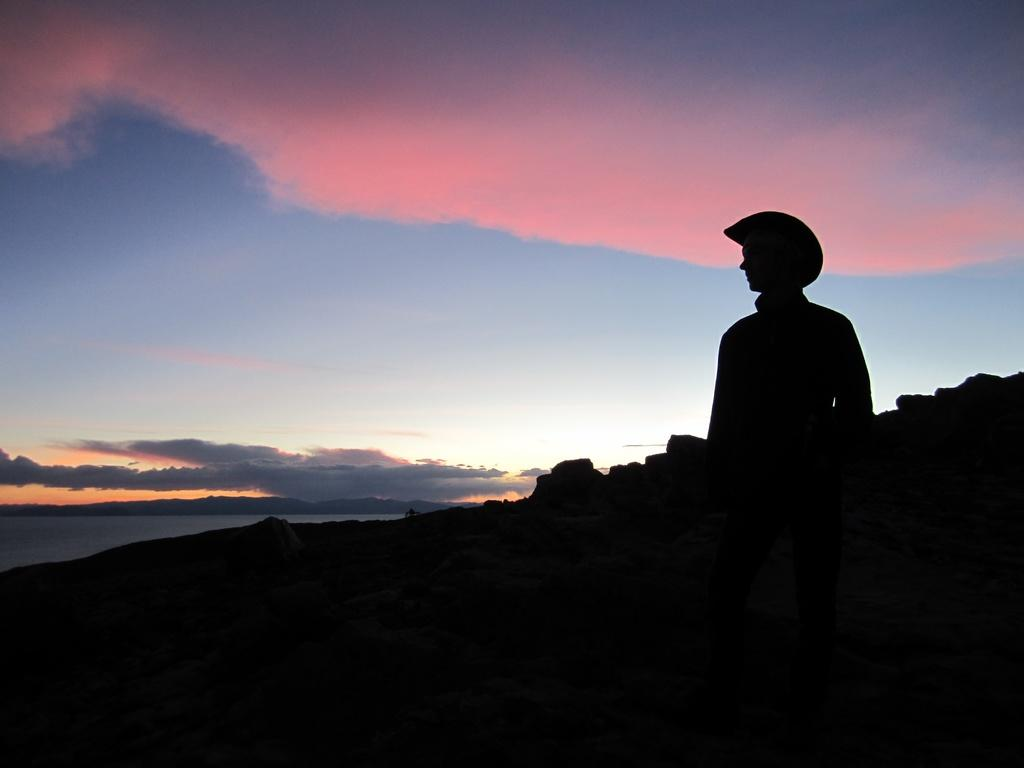What is the main subject of the image? There is a person standing in the image. What can be seen behind the person? There are stones behind the person. What is visible in the background of the image? The sky is visible in the background of the image. Where is the wax shop located in the image? There is no wax shop present in the image. What type of coastline can be seen in the image? There is no coastline visible in the image. 